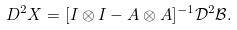<formula> <loc_0><loc_0><loc_500><loc_500>D ^ { 2 } X = [ I \otimes I - A \otimes A ] ^ { - 1 } \mathcal { D } ^ { 2 } \mathcal { B } .</formula> 